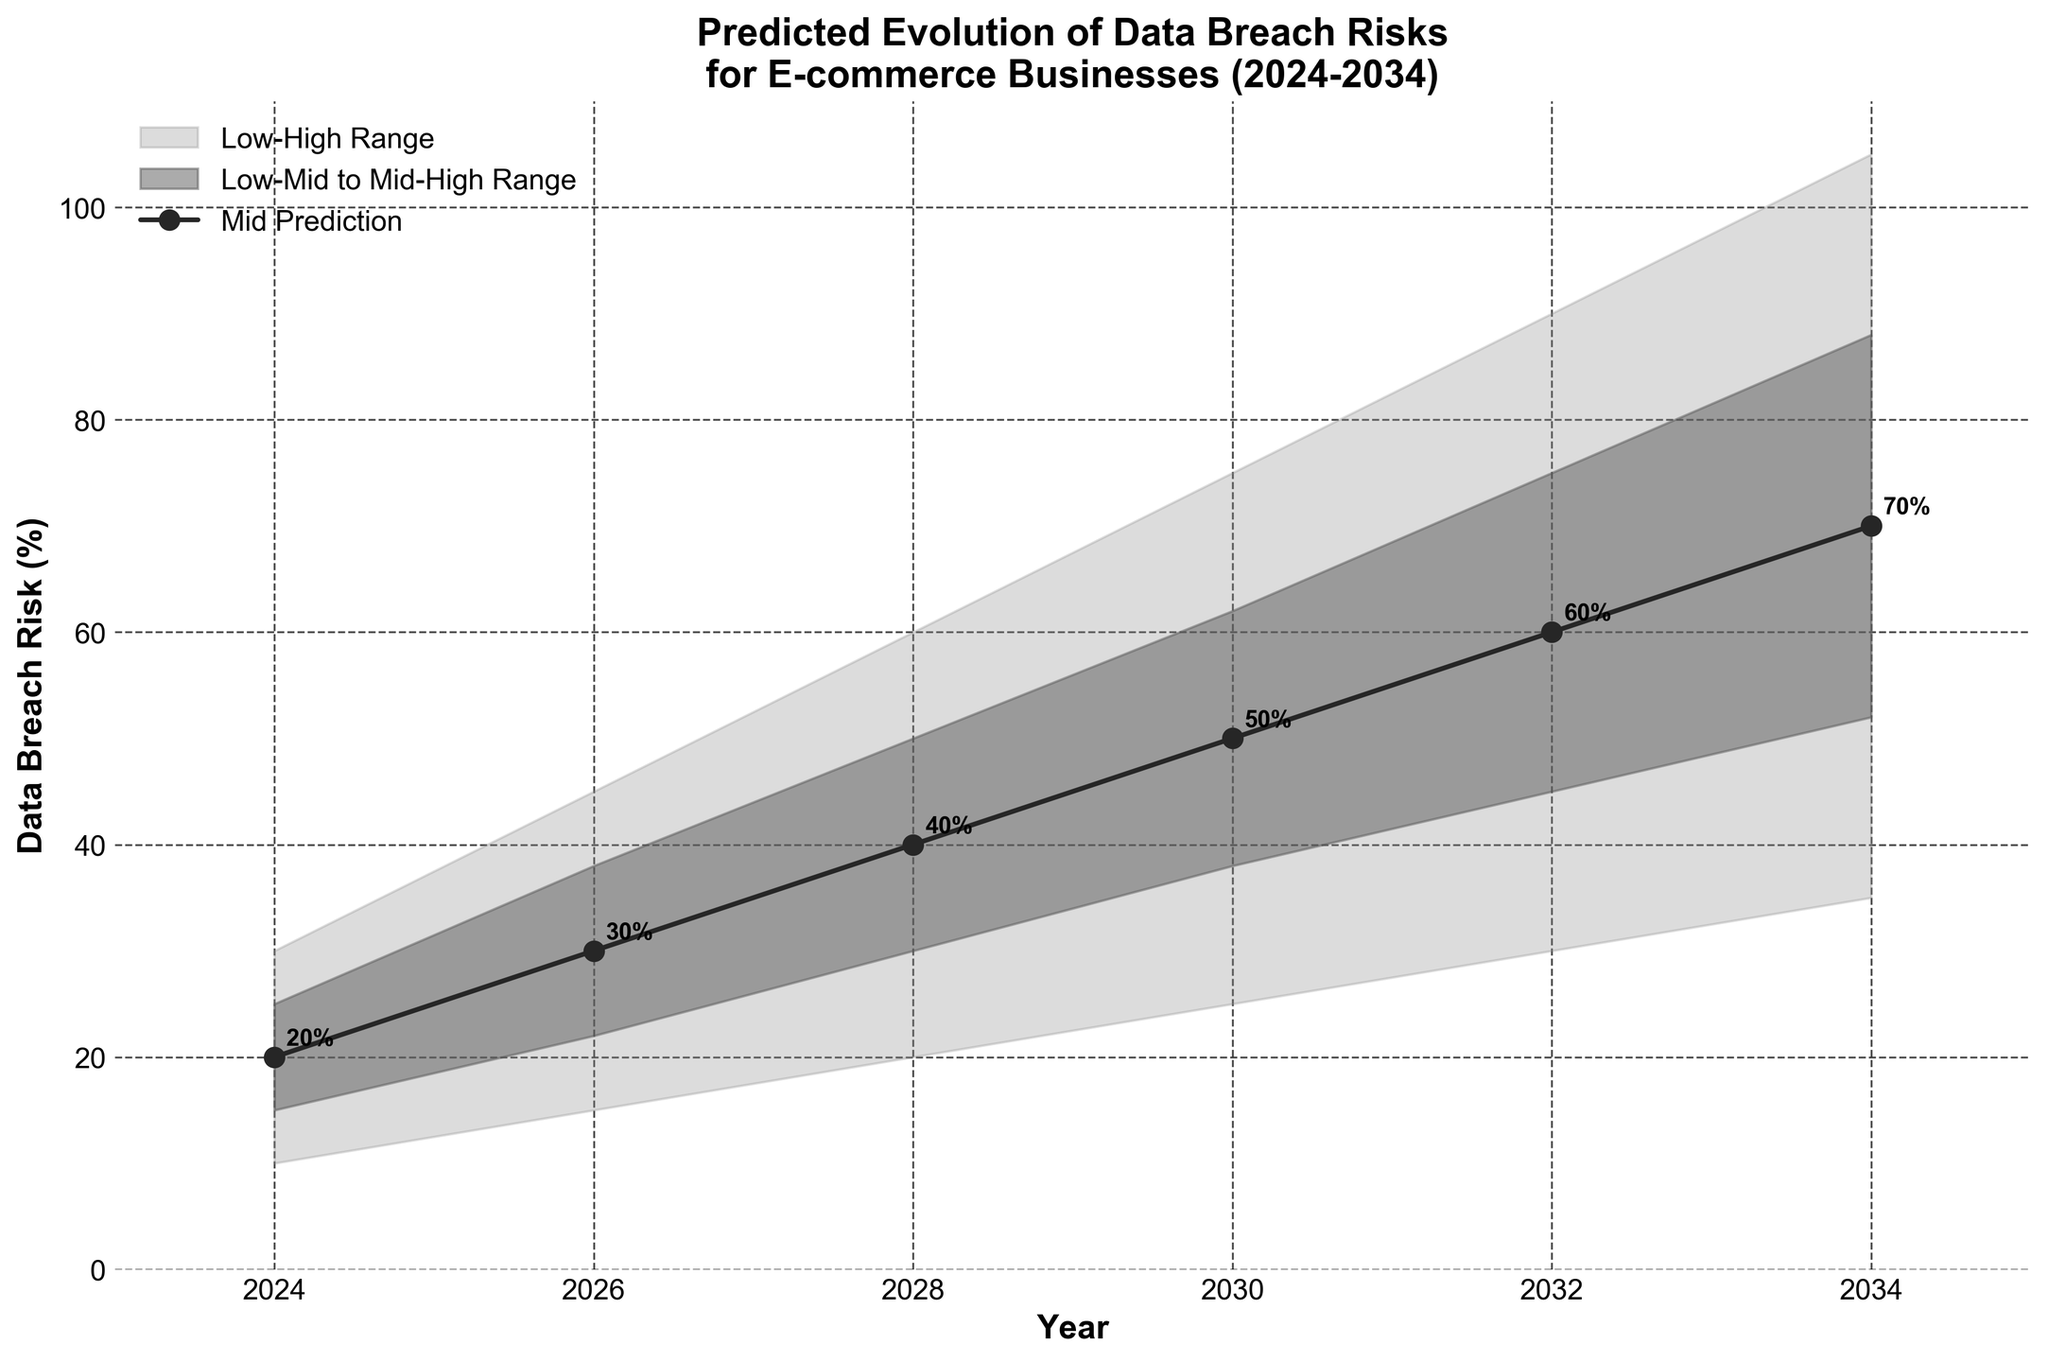What is the predicted mid-range data breach risk for e-commerce businesses in 2028? The mid-range prediction for 2028 is represented by the solid line with markers in the middle. The value for the year 2028 on this line is 40%.
Answer: 40% What is the range of data breach risks predicted for the year 2034? The range is represented by the shaded areas from Low to High. For 2034, the Low is 35% and the High is 105%.
Answer: 35% to 105% By how much does the mid-range prediction of data breach risk increase from 2026 to 2032? The mid-range prediction for 2026 is 30%, and for 2032, it is 60%. The increase is 60% - 30% = 30%.
Answer: 30% Which year shows the highest mid-range prediction for data breach risks and what is the value? The mid-range predictions are plotted as a line with markers. The highest value on this line is for the year 2034, at 70%.
Answer: 2034, 70% On average, how much does the low-end prediction of data breach risks increase every two years from 2024 to 2034? The low-end values are 10%, 15%, 20%, 25%, 30%, 35% for the years 2024, 2026, 2028, 2030, 2032, 2034, respectively. The total increase is 35%-10% = 25% over 10 years, so the average increase every two years is 25%/5 = 5%.
Answer: 5% How wide is the prediction interval (range between Low and High) for the year 2030? The Low prediction for 2030 is 25%, and the High is 75%. The width of the interval is 75% - 25% = 50%.
Answer: 50% By what factor does the high-end prediction of data breach risks increase from the year 2024 to 2034? The high-end predictions for 2024 and 2034 are 30% and 105%, respectively. The increase factor is 105% / 30% = 3.5.
Answer: 3.5 Compare the growth rate of low-end predictions to high-end predictions from 2028 to 2034. The low-end prediction increases from 20% in 2028 to 35% in 2034, an increase of 15%. The high-end prediction increases from 60% in 2028 to 105% in 2034, an increase of 45%. The growth rates can be compared by dividing these differences by the 2028 values: (15% / 20%) vs. (45% / 60%). The growth rates are 0.75 and 0.75, respectively.
Answer: Equal growth rates of 0.75 How does the predicted mid-range of data breach risk change from 2026 to 2028 and from 2032 to 2034? From 2026 to 2028, the mid-range prediction increases from 30% to 40%, a change of 10%. From 2032 to 2034, it increases from 60% to 70%, a change of 10%.
Answer: 10% and 10% What is the difference between the mid-high and low-mid predictions for the year 2030? The mid-high prediction for 2030 is 62% and the low-mid prediction is 38%. The difference is 62% - 38% = 24%.
Answer: 24% 